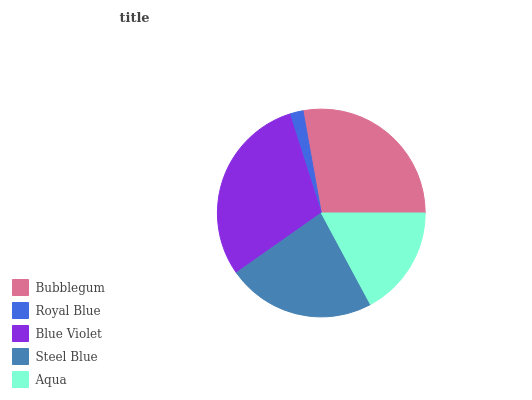Is Royal Blue the minimum?
Answer yes or no. Yes. Is Blue Violet the maximum?
Answer yes or no. Yes. Is Blue Violet the minimum?
Answer yes or no. No. Is Royal Blue the maximum?
Answer yes or no. No. Is Blue Violet greater than Royal Blue?
Answer yes or no. Yes. Is Royal Blue less than Blue Violet?
Answer yes or no. Yes. Is Royal Blue greater than Blue Violet?
Answer yes or no. No. Is Blue Violet less than Royal Blue?
Answer yes or no. No. Is Steel Blue the high median?
Answer yes or no. Yes. Is Steel Blue the low median?
Answer yes or no. Yes. Is Bubblegum the high median?
Answer yes or no. No. Is Aqua the low median?
Answer yes or no. No. 